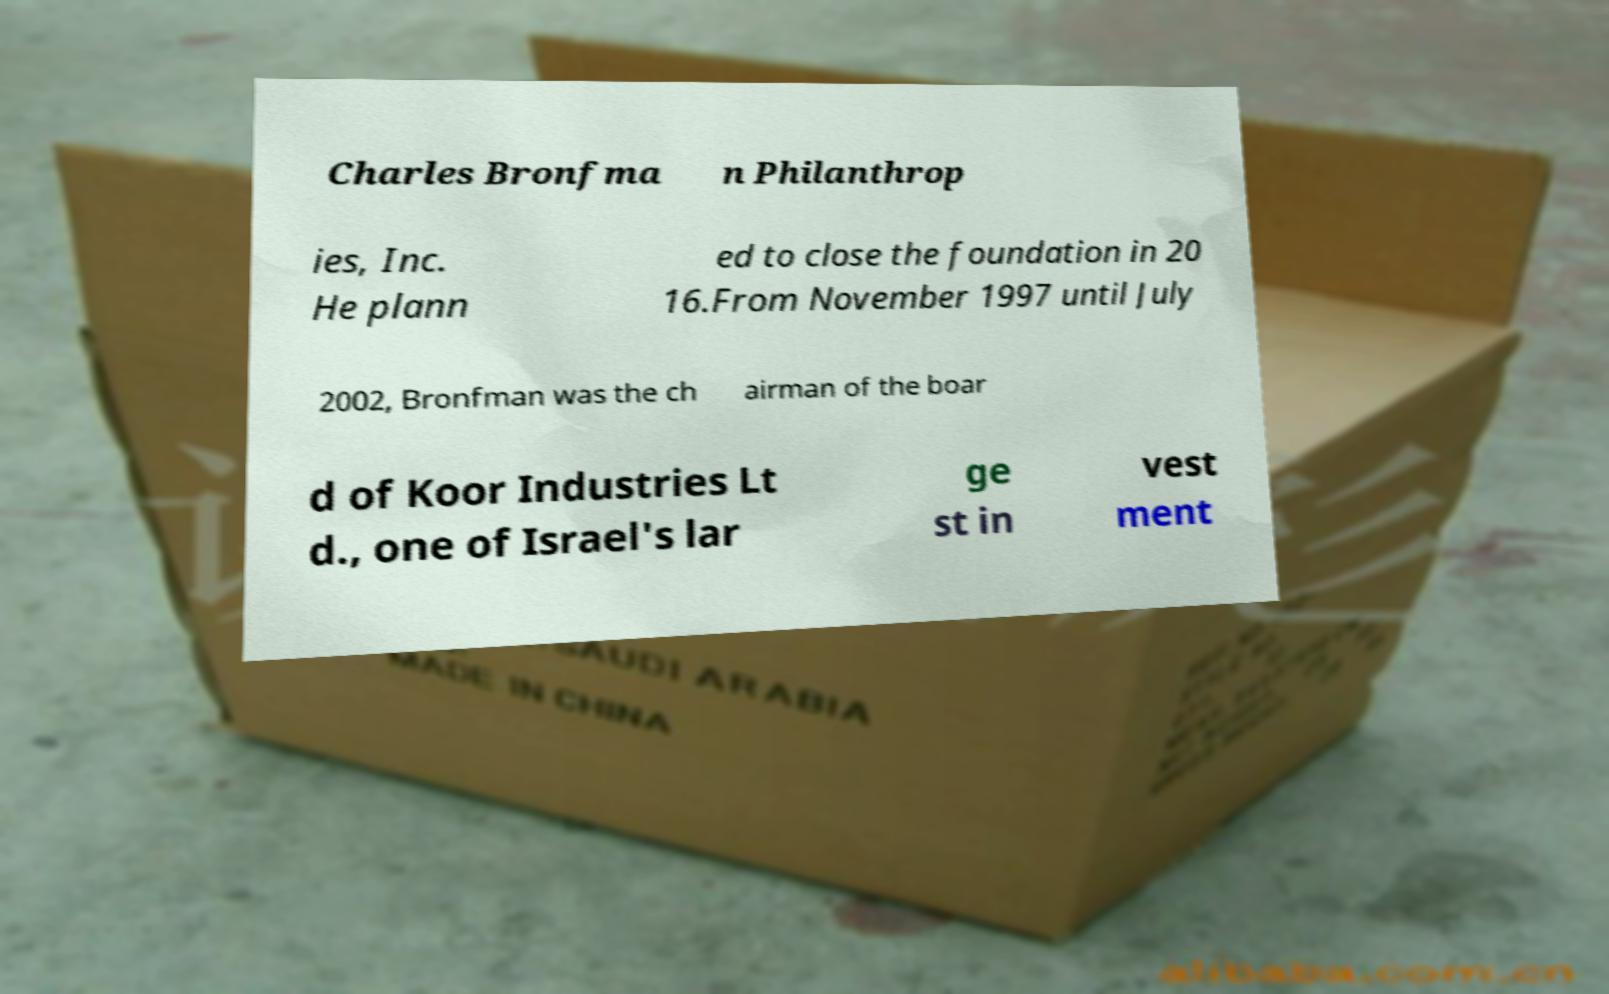Please read and relay the text visible in this image. What does it say? Charles Bronfma n Philanthrop ies, Inc. He plann ed to close the foundation in 20 16.From November 1997 until July 2002, Bronfman was the ch airman of the boar d of Koor Industries Lt d., one of Israel's lar ge st in vest ment 